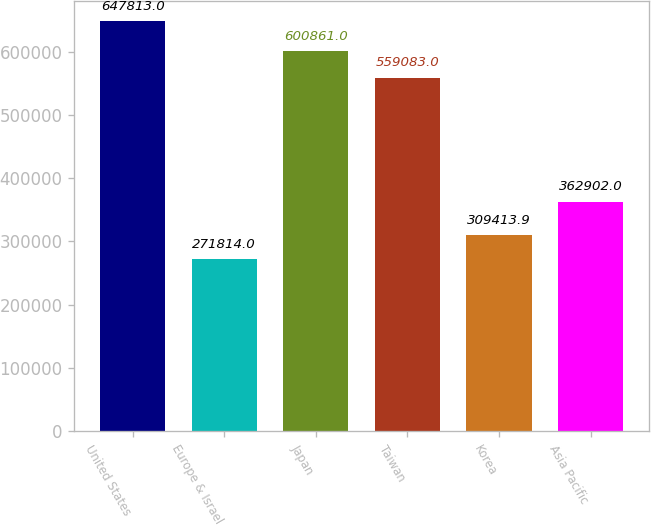Convert chart to OTSL. <chart><loc_0><loc_0><loc_500><loc_500><bar_chart><fcel>United States<fcel>Europe & Israel<fcel>Japan<fcel>Taiwan<fcel>Korea<fcel>Asia Pacific<nl><fcel>647813<fcel>271814<fcel>600861<fcel>559083<fcel>309414<fcel>362902<nl></chart> 